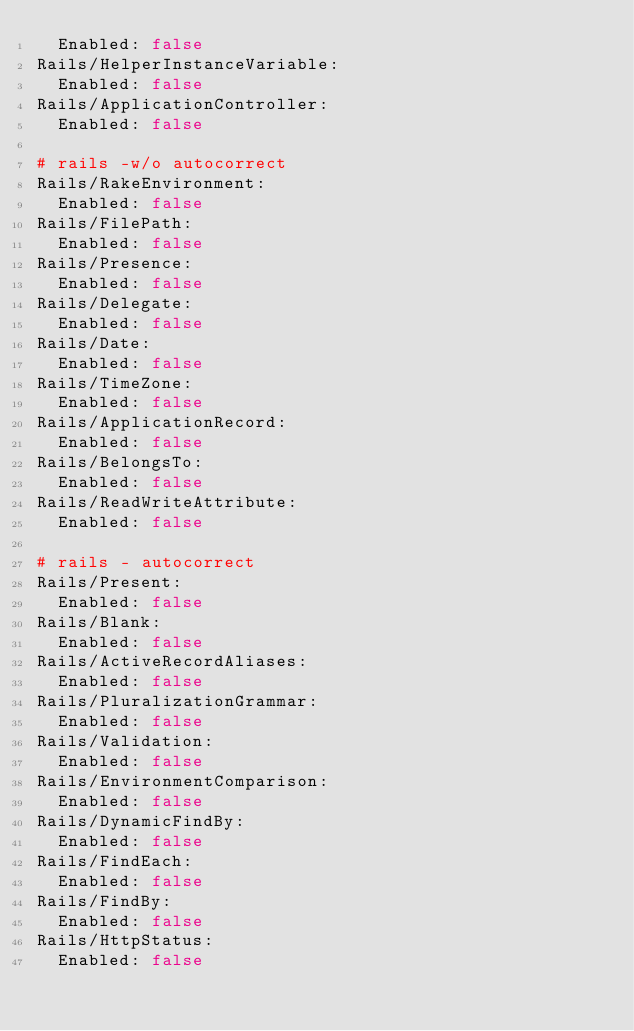<code> <loc_0><loc_0><loc_500><loc_500><_YAML_>  Enabled: false
Rails/HelperInstanceVariable:
  Enabled: false
Rails/ApplicationController:
  Enabled: false

# rails -w/o autocorrect
Rails/RakeEnvironment:
  Enabled: false
Rails/FilePath:
  Enabled: false
Rails/Presence:
  Enabled: false
Rails/Delegate:
  Enabled: false
Rails/Date:
  Enabled: false
Rails/TimeZone:
  Enabled: false
Rails/ApplicationRecord:
  Enabled: false
Rails/BelongsTo:
  Enabled: false
Rails/ReadWriteAttribute:
  Enabled: false

# rails - autocorrect
Rails/Present:
  Enabled: false
Rails/Blank:
  Enabled: false
Rails/ActiveRecordAliases:
  Enabled: false
Rails/PluralizationGrammar:
  Enabled: false
Rails/Validation:
  Enabled: false
Rails/EnvironmentComparison:
  Enabled: false
Rails/DynamicFindBy:
  Enabled: false
Rails/FindEach:
  Enabled: false
Rails/FindBy:
  Enabled: false
Rails/HttpStatus:
  Enabled: false
</code> 